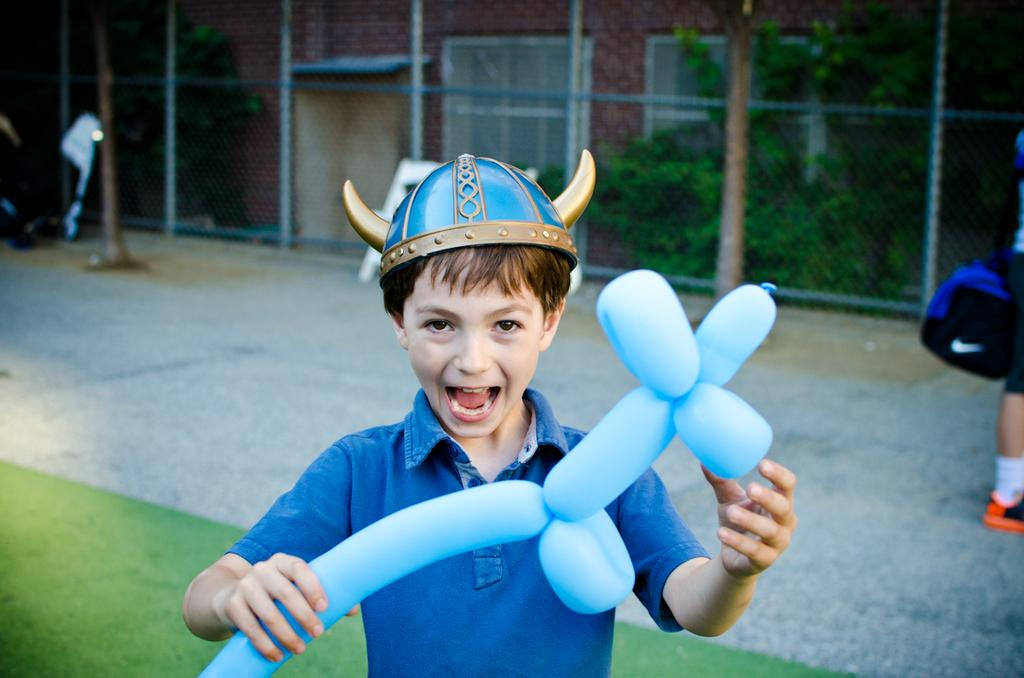What type of structures are visible in the image? There are buildings in the image. What is the barrier that separates the foreground and background of the image? There is a fence in the image. What type of plant is present in the image? There is a tree in the image. Who can be seen in the image? There are people in the image. Can you describe the boy in the image? A boy is standing in the front of the image, and he is holding a balloon. How many buttons are on the boy's shirt in the image? There is no information about the boy's shirt in the image, so we cannot determine the number of buttons. Are there any sisters in the image? The provided facts do not mention any sisters, so we cannot confirm their presence in the image. 